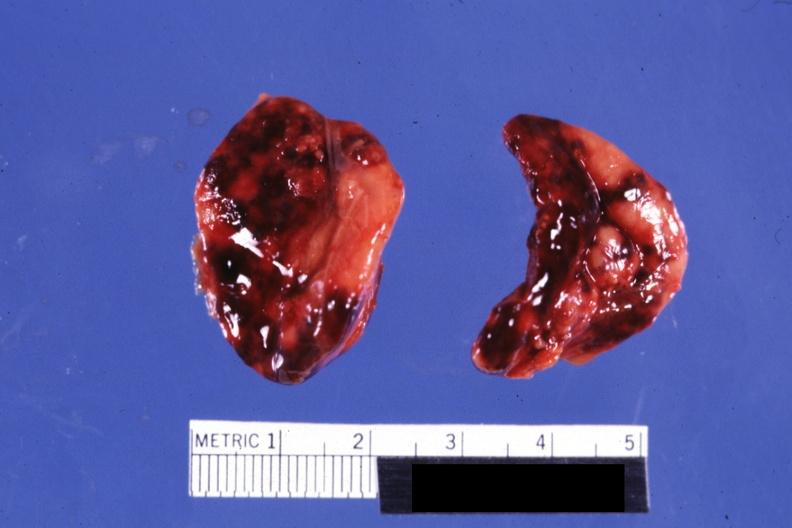how does both adrenals external views focal hemorrhages do not know history look like abruption?
Answer the question using a single word or phrase. Placental 